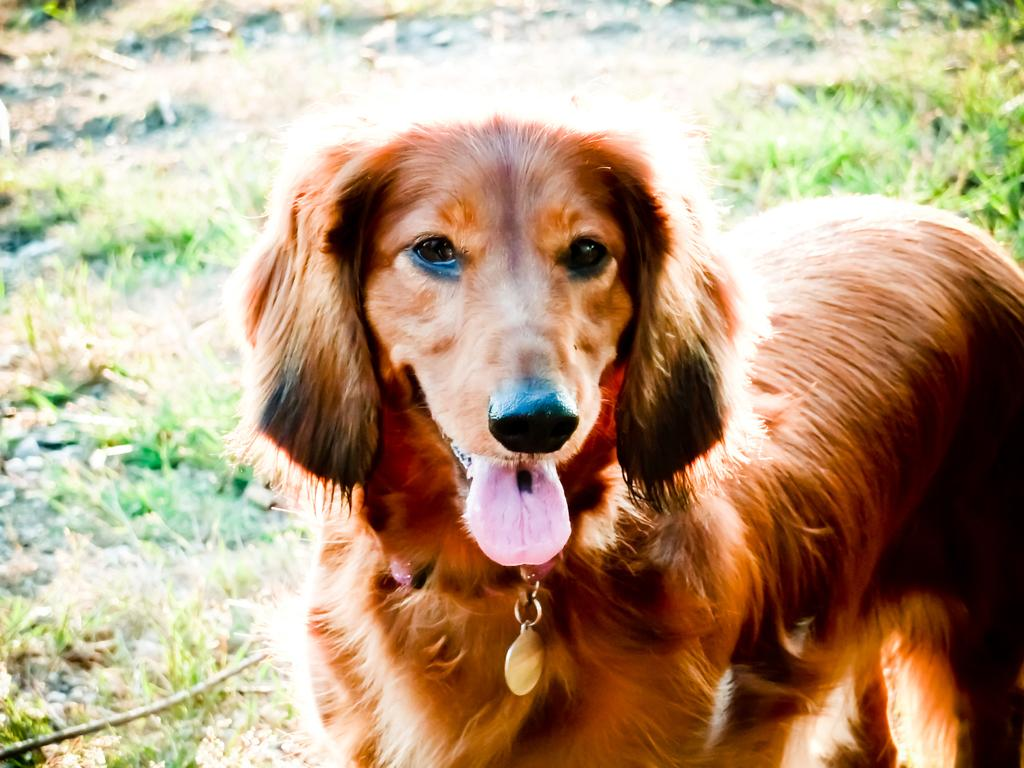What is the main subject in the foreground of the image? There is a dog in the foreground of the image. What type of environment is depicted in the background of the image? There is grass visible in the background of the image. What type of heart can be seen in the image? There is no heart present in the image; it features a dog in the foreground and grass in the background. 